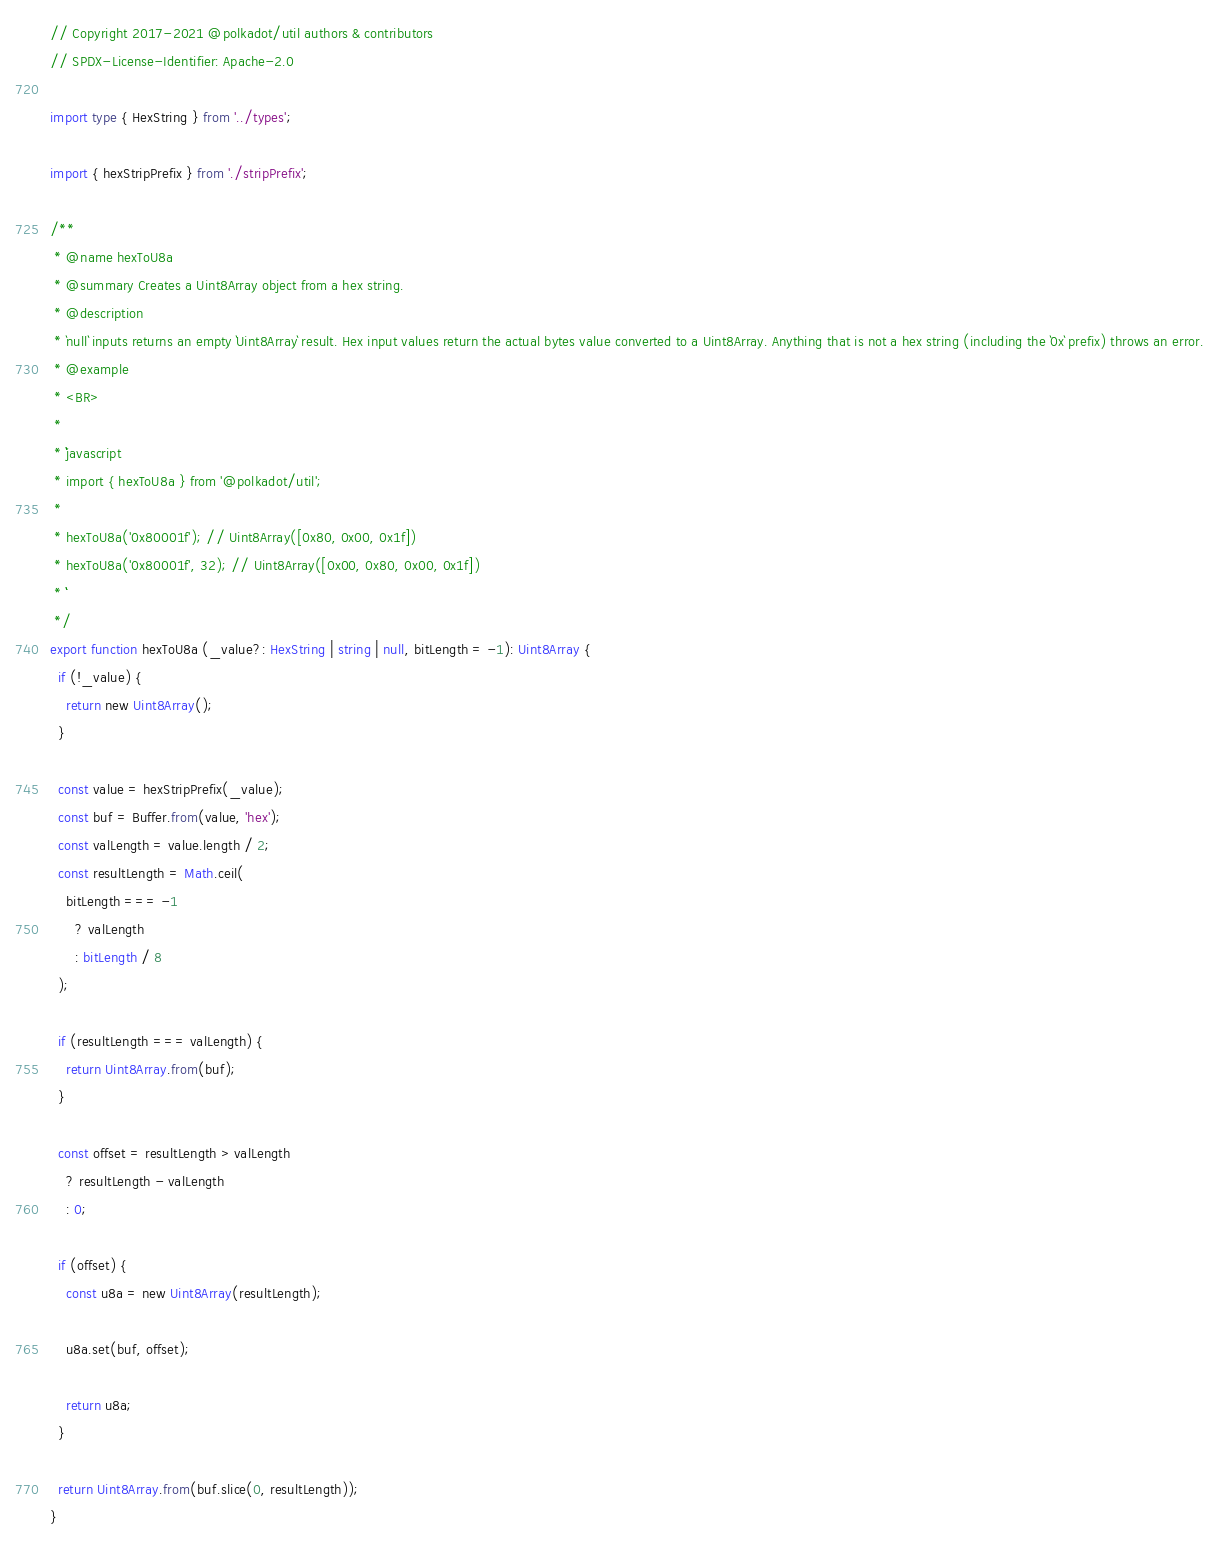Convert code to text. <code><loc_0><loc_0><loc_500><loc_500><_TypeScript_>// Copyright 2017-2021 @polkadot/util authors & contributors
// SPDX-License-Identifier: Apache-2.0

import type { HexString } from '../types';

import { hexStripPrefix } from './stripPrefix';

/**
 * @name hexToU8a
 * @summary Creates a Uint8Array object from a hex string.
 * @description
 * `null` inputs returns an empty `Uint8Array` result. Hex input values return the actual bytes value converted to a Uint8Array. Anything that is not a hex string (including the `0x` prefix) throws an error.
 * @example
 * <BR>
 *
 * ```javascript
 * import { hexToU8a } from '@polkadot/util';
 *
 * hexToU8a('0x80001f'); // Uint8Array([0x80, 0x00, 0x1f])
 * hexToU8a('0x80001f', 32); // Uint8Array([0x00, 0x80, 0x00, 0x1f])
 * ```
 */
export function hexToU8a (_value?: HexString | string | null, bitLength = -1): Uint8Array {
  if (!_value) {
    return new Uint8Array();
  }

  const value = hexStripPrefix(_value);
  const buf = Buffer.from(value, 'hex');
  const valLength = value.length / 2;
  const resultLength = Math.ceil(
    bitLength === -1
      ? valLength
      : bitLength / 8
  );

  if (resultLength === valLength) {
    return Uint8Array.from(buf);
  }

  const offset = resultLength > valLength
    ? resultLength - valLength
    : 0;

  if (offset) {
    const u8a = new Uint8Array(resultLength);

    u8a.set(buf, offset);

    return u8a;
  }

  return Uint8Array.from(buf.slice(0, resultLength));
}
</code> 